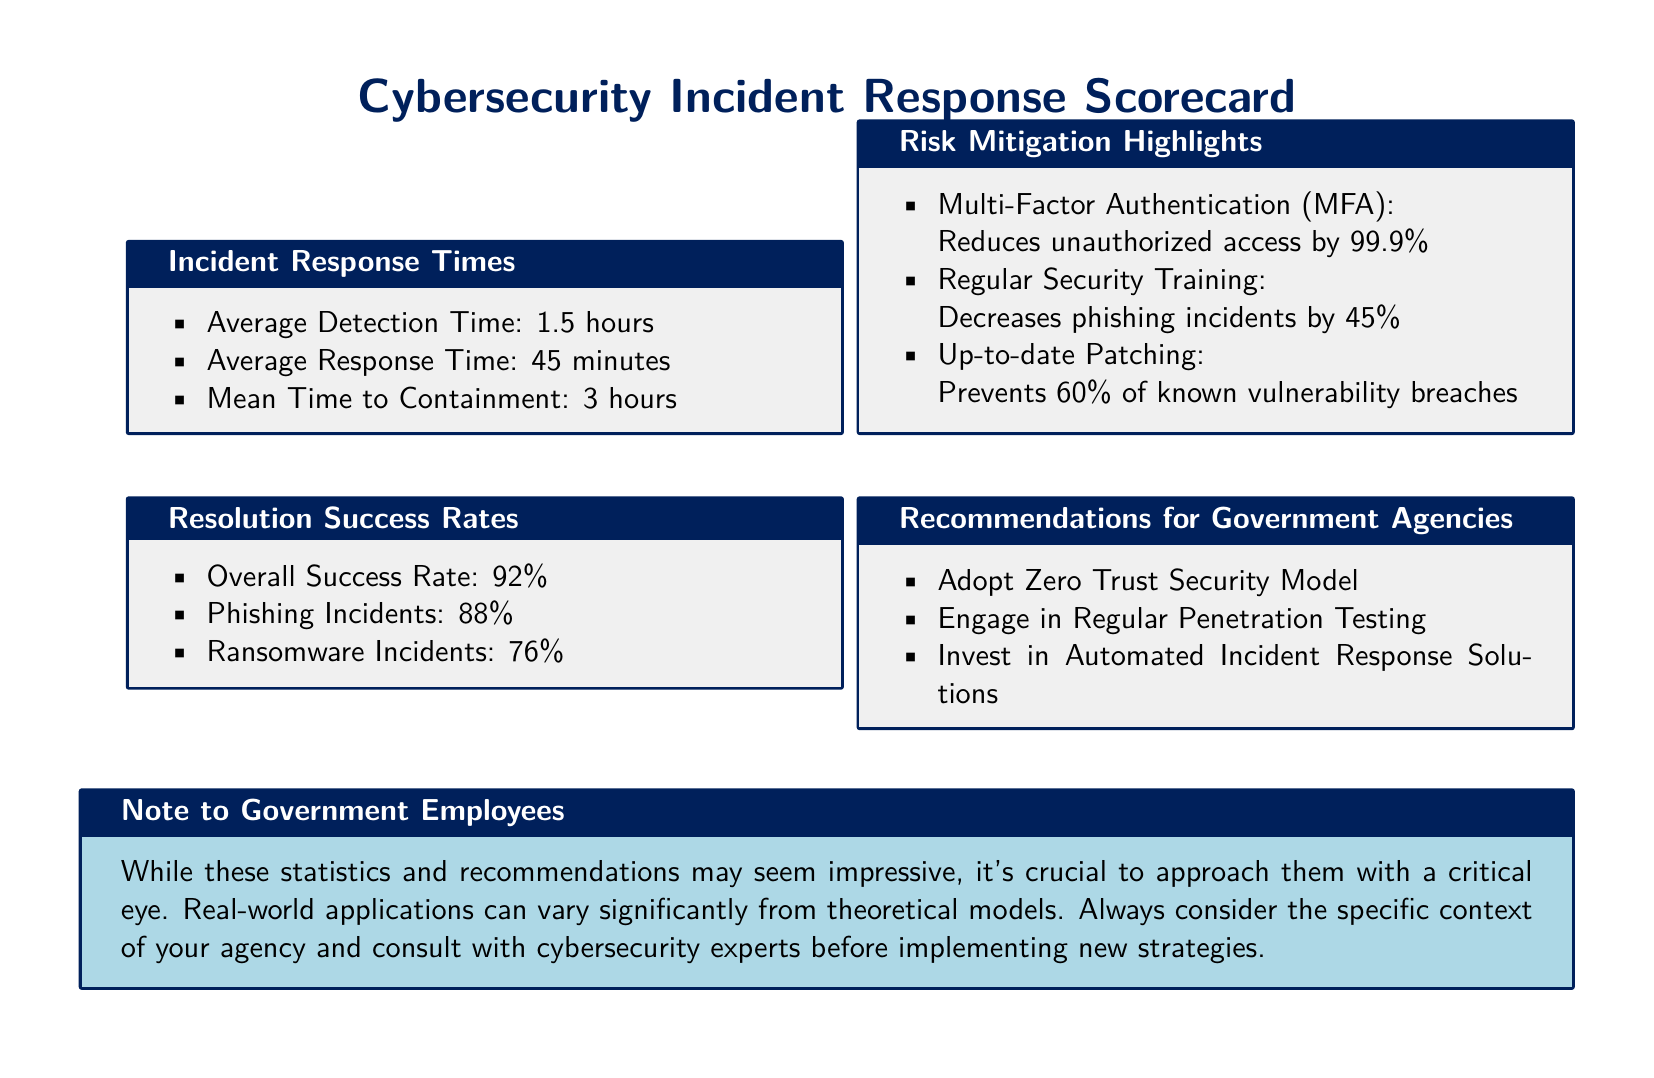What is the average detection time? The average detection time is listed in the "Incident Response Times" section of the document as 1.5 hours.
Answer: 1.5 hours What is the overall success rate for incident resolution? The overall success rate is mentioned in the "Resolution Success Rates" section as 92%.
Answer: 92% What reduces unauthorized access by 99.9%? The document notes that Multi-Factor Authentication (MFA) reduces unauthorized access by 99.9%.
Answer: Multi-Factor Authentication (MFA) What is the mean time to containment? The mean time to containment is provided under "Incident Response Times" as 3 hours.
Answer: 3 hours How much do regular security training efforts decrease phishing incidents? The "Risk Mitigation Highlights" section states that regular security training decreases phishing incidents by 45%.
Answer: 45% What recommendation is given for engaging in regular security practices? One of the recommendations for government agencies is to engage in regular penetration testing.
Answer: Engage in Regular Penetration Testing What is the success rate for ransomware incidents? The success rate for ransomware incidents is specified in the "Resolution Success Rates" section as 76%.
Answer: 76% What document type does this scorecard serve? The document is a Cybersecurity Incident Response Scorecard, indicating it provides performance metrics related to cybersecurity incident handling.
Answer: Cybersecurity Incident Response Scorecard 